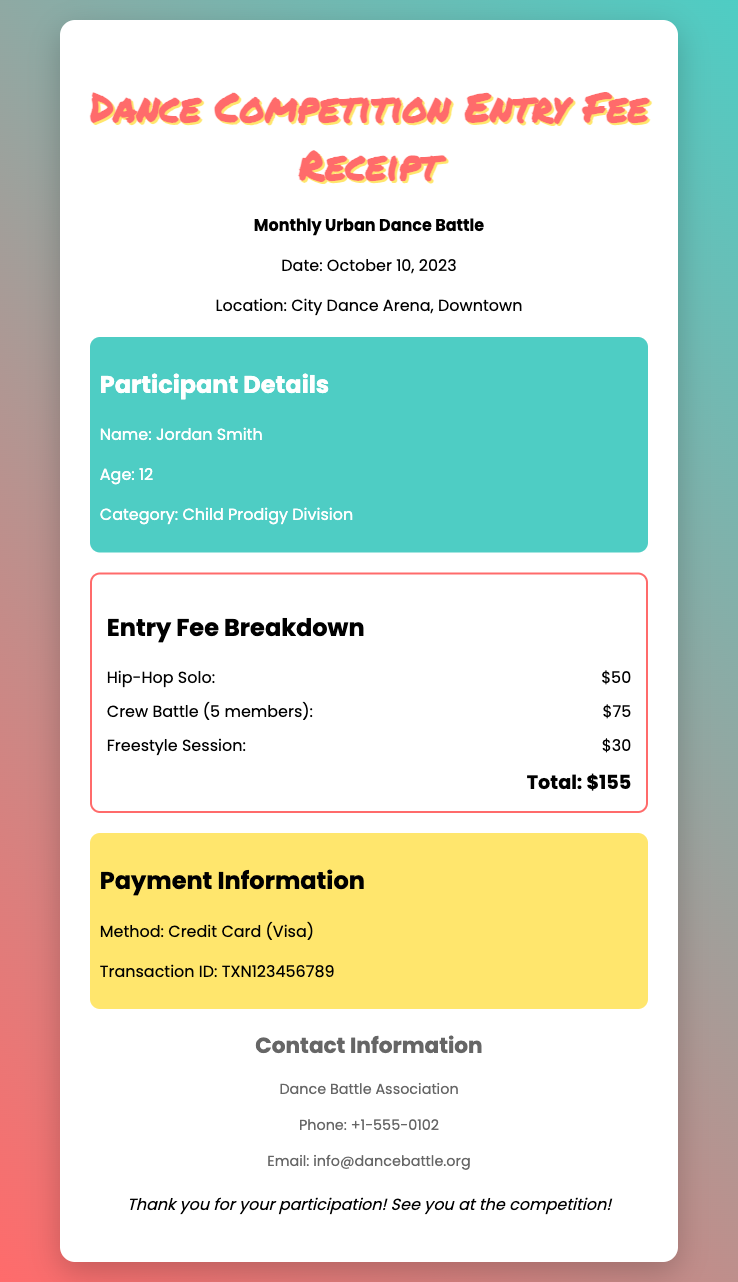What is the participant's name? The participant's name is clearly stated in the document under Participant Details.
Answer: Jordan Smith What is the total entry fee? The total entry fee is calculated from the breakdown of fees provided in the document.
Answer: $155 When is the competition date? The date of the competition is mentioned in the competition information section.
Answer: October 10, 2023 What category is the participant competing in? The participant's category is specified under Participant Details.
Answer: Child Prodigy Division What method was used for payment? The payment method is listed under Payment Information.
Answer: Credit Card (Visa) What is the location of the event? The location of the event is clearly mentioned in the competition information.
Answer: City Dance Arena, Downtown How many members are in the Crew Battle? The number of members in the Crew Battle is indicated in the fee breakdown.
Answer: 5 members What is the transaction ID? The transaction ID is provided in the Payment Information section.
Answer: TXN123456789 What is the contact phone number? The contact phone number for the Dance Battle Association is available in the contact information section.
Answer: +1-555-0102 